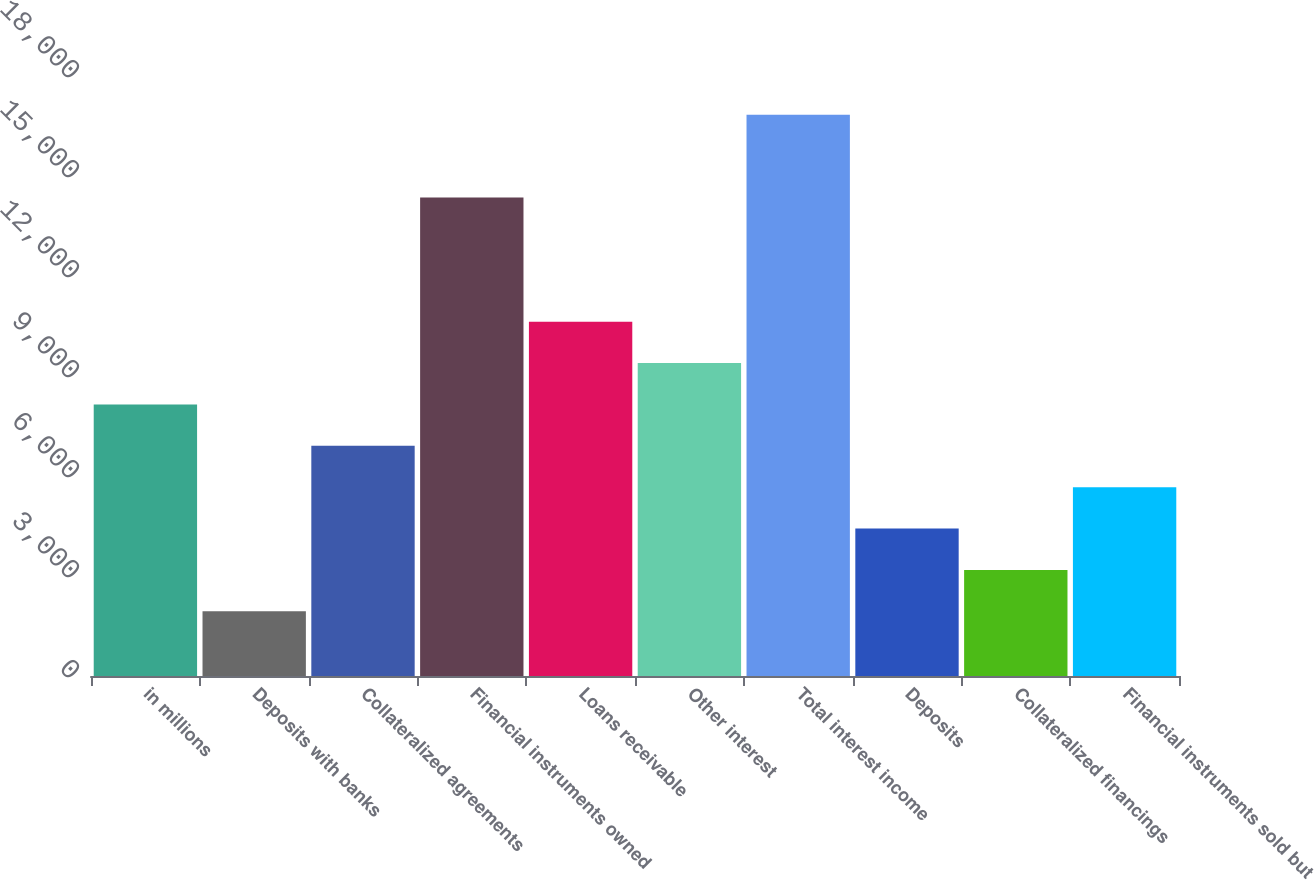Convert chart to OTSL. <chart><loc_0><loc_0><loc_500><loc_500><bar_chart><fcel>in millions<fcel>Deposits with banks<fcel>Collateralized agreements<fcel>Financial instruments owned<fcel>Loans receivable<fcel>Other interest<fcel>Total interest income<fcel>Deposits<fcel>Collateralized financings<fcel>Financial instruments sold but<nl><fcel>8147<fcel>1939.5<fcel>6905.5<fcel>14354.5<fcel>10630<fcel>9388.5<fcel>16837.5<fcel>4422.5<fcel>3181<fcel>5664<nl></chart> 